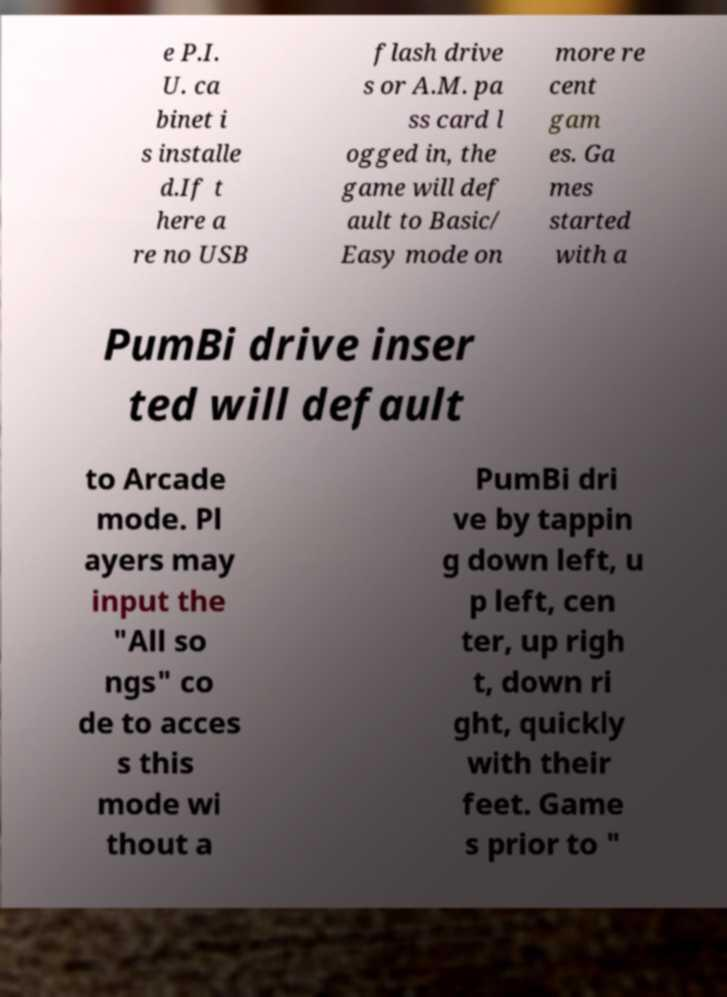For documentation purposes, I need the text within this image transcribed. Could you provide that? e P.I. U. ca binet i s installe d.If t here a re no USB flash drive s or A.M. pa ss card l ogged in, the game will def ault to Basic/ Easy mode on more re cent gam es. Ga mes started with a PumBi drive inser ted will default to Arcade mode. Pl ayers may input the "All so ngs" co de to acces s this mode wi thout a PumBi dri ve by tappin g down left, u p left, cen ter, up righ t, down ri ght, quickly with their feet. Game s prior to " 